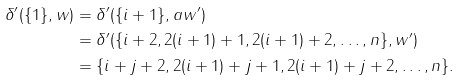Convert formula to latex. <formula><loc_0><loc_0><loc_500><loc_500>\delta ^ { \prime } ( \{ 1 \} , w ) & = \delta ^ { \prime } ( \{ i + 1 \} , a w ^ { \prime } ) \\ & = \delta ^ { \prime } ( \{ i + 2 , 2 ( i + 1 ) + 1 , 2 ( i + 1 ) + 2 , \dots , n \} , w ^ { \prime } ) \\ & = \{ i + j + 2 , 2 ( i + 1 ) + j + 1 , 2 ( i + 1 ) + j + 2 , \dots , n \} .</formula> 